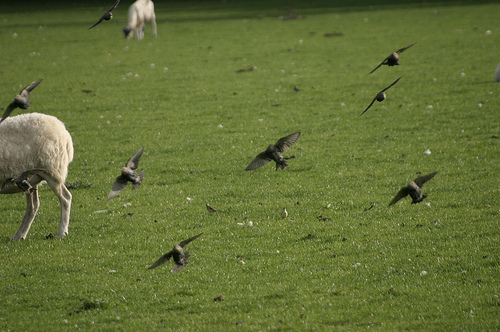Please provide a short description for this region: [0.23, 0.19, 0.35, 0.26]. In the specified area, a sheep is captured while eating grass, contributing to a serene pastoral scene. 